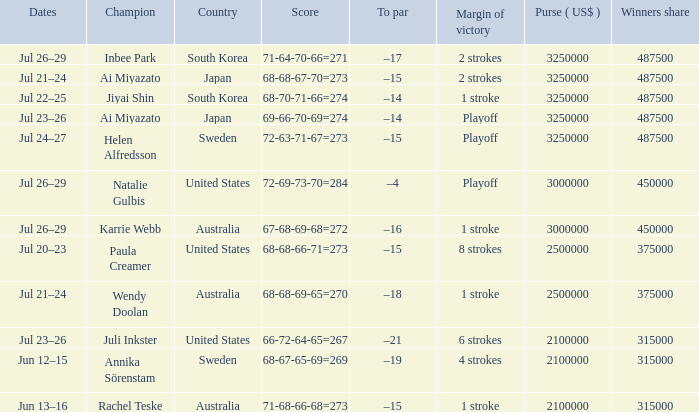Over how many years was jiyai shin a champion? 1.0. 